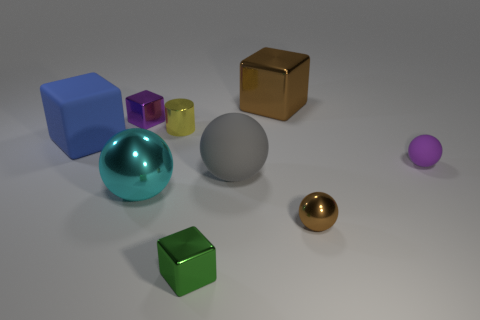Is there any other thing that is the same shape as the yellow thing?
Keep it short and to the point. No. How many small things are on the right side of the large brown metallic cube and in front of the cyan metal thing?
Keep it short and to the point. 1. What is the shape of the thing that is the same color as the tiny metal sphere?
Your response must be concise. Cube. What is the material of the small object that is both in front of the gray sphere and on the left side of the small metallic sphere?
Offer a very short reply. Metal. Is the number of brown shiny balls on the left side of the large cyan thing less than the number of tiny metallic blocks that are on the right side of the purple cube?
Provide a short and direct response. Yes. What size is the purple block that is the same material as the small yellow object?
Keep it short and to the point. Small. Are there any other things of the same color as the metallic cylinder?
Your answer should be compact. No. Are the gray thing and the tiny purple object that is on the right side of the cyan object made of the same material?
Offer a very short reply. Yes. There is a brown thing that is the same shape as the blue matte thing; what material is it?
Provide a short and direct response. Metal. Are there any other things that have the same material as the brown cube?
Offer a terse response. Yes. 